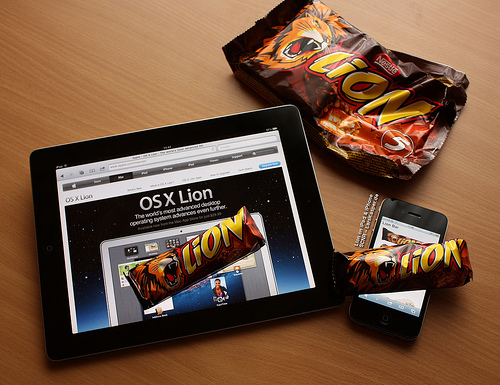<image>
Can you confirm if the tablet is on the table? Yes. Looking at the image, I can see the tablet is positioned on top of the table, with the table providing support. Is the lion bar above the table? Yes. The lion bar is positioned above the table in the vertical space, higher up in the scene. 